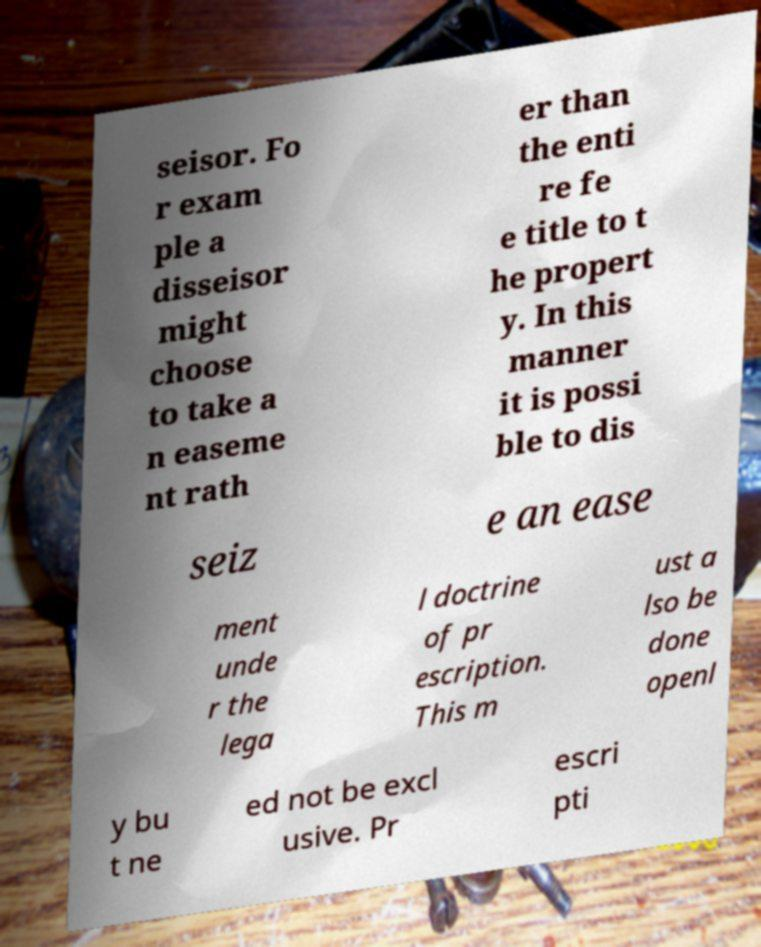Can you read and provide the text displayed in the image?This photo seems to have some interesting text. Can you extract and type it out for me? seisor. Fo r exam ple a disseisor might choose to take a n easeme nt rath er than the enti re fe e title to t he propert y. In this manner it is possi ble to dis seiz e an ease ment unde r the lega l doctrine of pr escription. This m ust a lso be done openl y bu t ne ed not be excl usive. Pr escri pti 